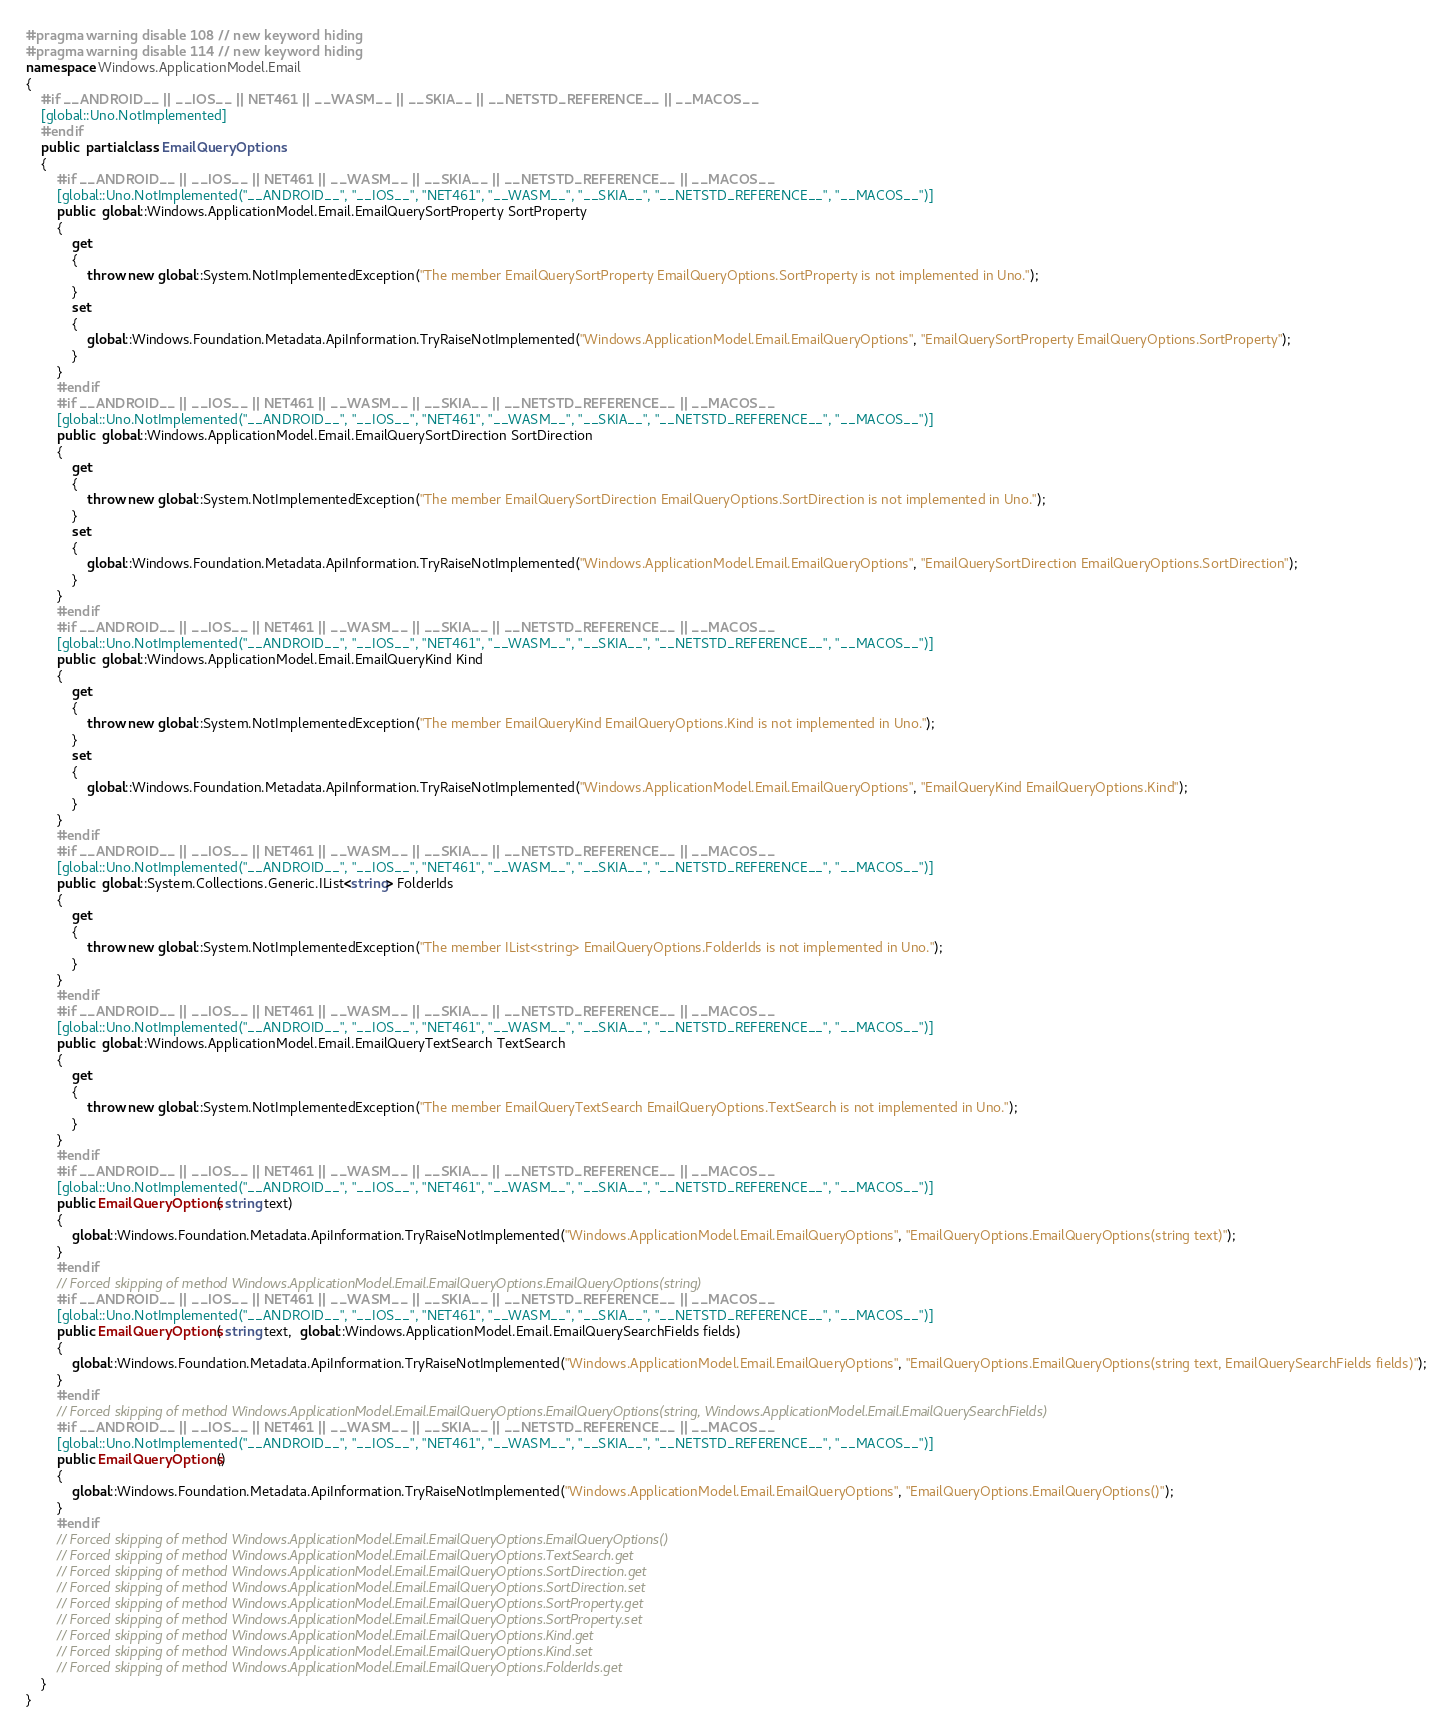Convert code to text. <code><loc_0><loc_0><loc_500><loc_500><_C#_>#pragma warning disable 108 // new keyword hiding
#pragma warning disable 114 // new keyword hiding
namespace Windows.ApplicationModel.Email
{
	#if __ANDROID__ || __IOS__ || NET461 || __WASM__ || __SKIA__ || __NETSTD_REFERENCE__ || __MACOS__
	[global::Uno.NotImplemented]
	#endif
	public  partial class EmailQueryOptions 
	{
		#if __ANDROID__ || __IOS__ || NET461 || __WASM__ || __SKIA__ || __NETSTD_REFERENCE__ || __MACOS__
		[global::Uno.NotImplemented("__ANDROID__", "__IOS__", "NET461", "__WASM__", "__SKIA__", "__NETSTD_REFERENCE__", "__MACOS__")]
		public  global::Windows.ApplicationModel.Email.EmailQuerySortProperty SortProperty
		{
			get
			{
				throw new global::System.NotImplementedException("The member EmailQuerySortProperty EmailQueryOptions.SortProperty is not implemented in Uno.");
			}
			set
			{
				global::Windows.Foundation.Metadata.ApiInformation.TryRaiseNotImplemented("Windows.ApplicationModel.Email.EmailQueryOptions", "EmailQuerySortProperty EmailQueryOptions.SortProperty");
			}
		}
		#endif
		#if __ANDROID__ || __IOS__ || NET461 || __WASM__ || __SKIA__ || __NETSTD_REFERENCE__ || __MACOS__
		[global::Uno.NotImplemented("__ANDROID__", "__IOS__", "NET461", "__WASM__", "__SKIA__", "__NETSTD_REFERENCE__", "__MACOS__")]
		public  global::Windows.ApplicationModel.Email.EmailQuerySortDirection SortDirection
		{
			get
			{
				throw new global::System.NotImplementedException("The member EmailQuerySortDirection EmailQueryOptions.SortDirection is not implemented in Uno.");
			}
			set
			{
				global::Windows.Foundation.Metadata.ApiInformation.TryRaiseNotImplemented("Windows.ApplicationModel.Email.EmailQueryOptions", "EmailQuerySortDirection EmailQueryOptions.SortDirection");
			}
		}
		#endif
		#if __ANDROID__ || __IOS__ || NET461 || __WASM__ || __SKIA__ || __NETSTD_REFERENCE__ || __MACOS__
		[global::Uno.NotImplemented("__ANDROID__", "__IOS__", "NET461", "__WASM__", "__SKIA__", "__NETSTD_REFERENCE__", "__MACOS__")]
		public  global::Windows.ApplicationModel.Email.EmailQueryKind Kind
		{
			get
			{
				throw new global::System.NotImplementedException("The member EmailQueryKind EmailQueryOptions.Kind is not implemented in Uno.");
			}
			set
			{
				global::Windows.Foundation.Metadata.ApiInformation.TryRaiseNotImplemented("Windows.ApplicationModel.Email.EmailQueryOptions", "EmailQueryKind EmailQueryOptions.Kind");
			}
		}
		#endif
		#if __ANDROID__ || __IOS__ || NET461 || __WASM__ || __SKIA__ || __NETSTD_REFERENCE__ || __MACOS__
		[global::Uno.NotImplemented("__ANDROID__", "__IOS__", "NET461", "__WASM__", "__SKIA__", "__NETSTD_REFERENCE__", "__MACOS__")]
		public  global::System.Collections.Generic.IList<string> FolderIds
		{
			get
			{
				throw new global::System.NotImplementedException("The member IList<string> EmailQueryOptions.FolderIds is not implemented in Uno.");
			}
		}
		#endif
		#if __ANDROID__ || __IOS__ || NET461 || __WASM__ || __SKIA__ || __NETSTD_REFERENCE__ || __MACOS__
		[global::Uno.NotImplemented("__ANDROID__", "__IOS__", "NET461", "__WASM__", "__SKIA__", "__NETSTD_REFERENCE__", "__MACOS__")]
		public  global::Windows.ApplicationModel.Email.EmailQueryTextSearch TextSearch
		{
			get
			{
				throw new global::System.NotImplementedException("The member EmailQueryTextSearch EmailQueryOptions.TextSearch is not implemented in Uno.");
			}
		}
		#endif
		#if __ANDROID__ || __IOS__ || NET461 || __WASM__ || __SKIA__ || __NETSTD_REFERENCE__ || __MACOS__
		[global::Uno.NotImplemented("__ANDROID__", "__IOS__", "NET461", "__WASM__", "__SKIA__", "__NETSTD_REFERENCE__", "__MACOS__")]
		public EmailQueryOptions( string text) 
		{
			global::Windows.Foundation.Metadata.ApiInformation.TryRaiseNotImplemented("Windows.ApplicationModel.Email.EmailQueryOptions", "EmailQueryOptions.EmailQueryOptions(string text)");
		}
		#endif
		// Forced skipping of method Windows.ApplicationModel.Email.EmailQueryOptions.EmailQueryOptions(string)
		#if __ANDROID__ || __IOS__ || NET461 || __WASM__ || __SKIA__ || __NETSTD_REFERENCE__ || __MACOS__
		[global::Uno.NotImplemented("__ANDROID__", "__IOS__", "NET461", "__WASM__", "__SKIA__", "__NETSTD_REFERENCE__", "__MACOS__")]
		public EmailQueryOptions( string text,  global::Windows.ApplicationModel.Email.EmailQuerySearchFields fields) 
		{
			global::Windows.Foundation.Metadata.ApiInformation.TryRaiseNotImplemented("Windows.ApplicationModel.Email.EmailQueryOptions", "EmailQueryOptions.EmailQueryOptions(string text, EmailQuerySearchFields fields)");
		}
		#endif
		// Forced skipping of method Windows.ApplicationModel.Email.EmailQueryOptions.EmailQueryOptions(string, Windows.ApplicationModel.Email.EmailQuerySearchFields)
		#if __ANDROID__ || __IOS__ || NET461 || __WASM__ || __SKIA__ || __NETSTD_REFERENCE__ || __MACOS__
		[global::Uno.NotImplemented("__ANDROID__", "__IOS__", "NET461", "__WASM__", "__SKIA__", "__NETSTD_REFERENCE__", "__MACOS__")]
		public EmailQueryOptions() 
		{
			global::Windows.Foundation.Metadata.ApiInformation.TryRaiseNotImplemented("Windows.ApplicationModel.Email.EmailQueryOptions", "EmailQueryOptions.EmailQueryOptions()");
		}
		#endif
		// Forced skipping of method Windows.ApplicationModel.Email.EmailQueryOptions.EmailQueryOptions()
		// Forced skipping of method Windows.ApplicationModel.Email.EmailQueryOptions.TextSearch.get
		// Forced skipping of method Windows.ApplicationModel.Email.EmailQueryOptions.SortDirection.get
		// Forced skipping of method Windows.ApplicationModel.Email.EmailQueryOptions.SortDirection.set
		// Forced skipping of method Windows.ApplicationModel.Email.EmailQueryOptions.SortProperty.get
		// Forced skipping of method Windows.ApplicationModel.Email.EmailQueryOptions.SortProperty.set
		// Forced skipping of method Windows.ApplicationModel.Email.EmailQueryOptions.Kind.get
		// Forced skipping of method Windows.ApplicationModel.Email.EmailQueryOptions.Kind.set
		// Forced skipping of method Windows.ApplicationModel.Email.EmailQueryOptions.FolderIds.get
	}
}
</code> 